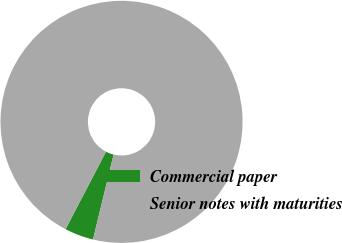<chart> <loc_0><loc_0><loc_500><loc_500><pie_chart><fcel>Commercial paper<fcel>Senior notes with maturities<nl><fcel>3.87%<fcel>96.13%<nl></chart> 